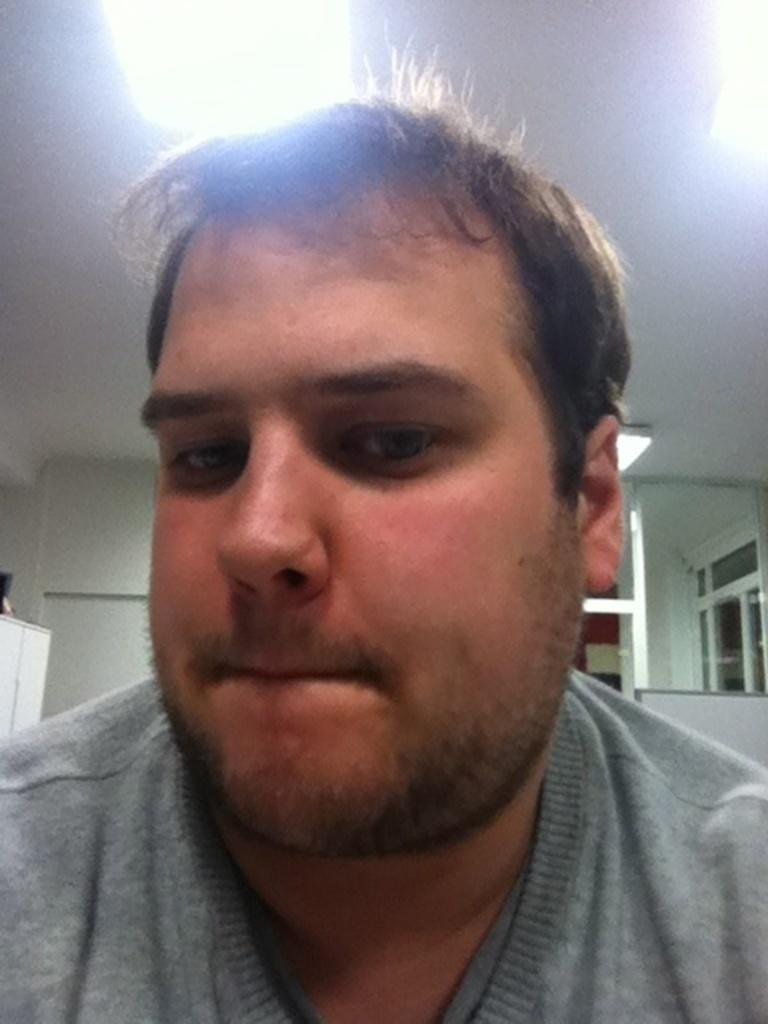Who is present in the image? There is a man in the image. What can be seen in the background of the image? There is a wall and a ceiling in the background of the image. Are there any objects visible in the background? Yes, there are objects visible in the background of the image. How many snails can be seen crawling on the man's shoulder in the image? There are no snails visible in the image; the man is alone in the image. 